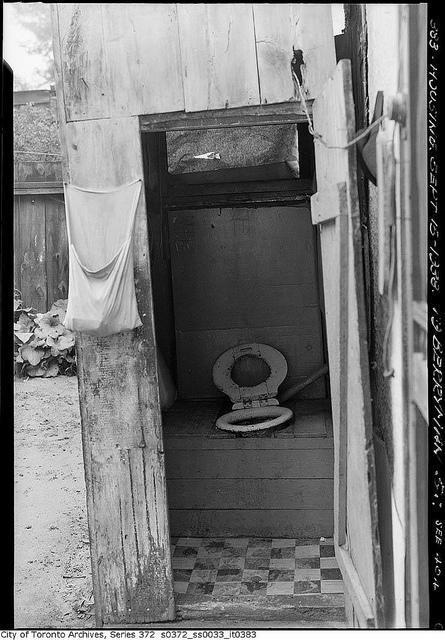How many sinks are there?
Give a very brief answer. 0. 